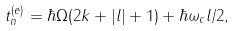<formula> <loc_0><loc_0><loc_500><loc_500>t _ { n } ^ { ( e ) } = \hbar { \Omega } ( 2 k + | l | + 1 ) + \hbar { \omega } _ { c } l / 2 ,</formula> 